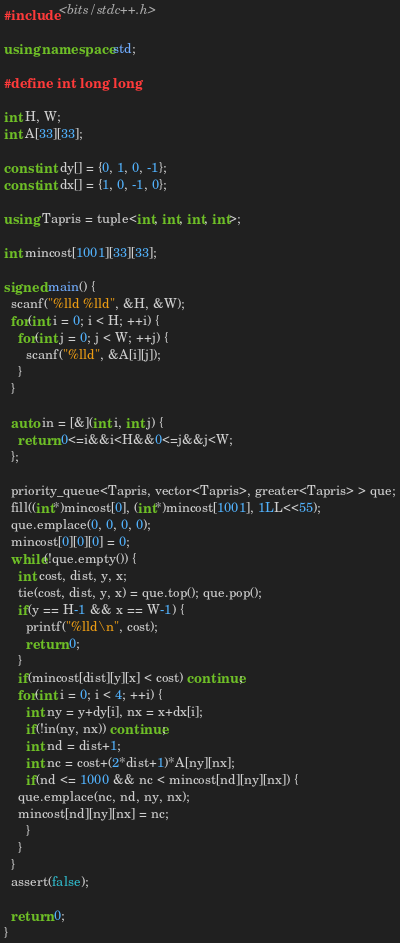Convert code to text. <code><loc_0><loc_0><loc_500><loc_500><_C++_>#include <bits/stdc++.h>

using namespace std;

#define int long long

int H, W;
int A[33][33];

const int dy[] = {0, 1, 0, -1};
const int dx[] = {1, 0, -1, 0};

using Tapris = tuple<int, int, int, int>;

int mincost[1001][33][33];

signed main() {
  scanf("%lld %lld", &H, &W);
  for(int i = 0; i < H; ++i) {
    for(int j = 0; j < W; ++j) {
      scanf("%lld", &A[i][j]);
    }
  }

  auto in = [&](int i, int j) {
    return 0<=i&&i<H&&0<=j&&j<W;
  };

  priority_queue<Tapris, vector<Tapris>, greater<Tapris> > que;
  fill((int*)mincost[0], (int*)mincost[1001], 1LL<<55);
  que.emplace(0, 0, 0, 0);
  mincost[0][0][0] = 0;
  while(!que.empty()) {
    int cost, dist, y, x;
    tie(cost, dist, y, x) = que.top(); que.pop();
    if(y == H-1 && x == W-1) {
      printf("%lld\n", cost);
      return 0;
    }
    if(mincost[dist][y][x] < cost) continue;
    for(int i = 0; i < 4; ++i) {
      int ny = y+dy[i], nx = x+dx[i];
      if(!in(ny, nx)) continue;
      int nd = dist+1;
      int nc = cost+(2*dist+1)*A[ny][nx];
      if(nd <= 1000 && nc < mincost[nd][ny][nx]) {
	que.emplace(nc, nd, ny, nx);
	mincost[nd][ny][nx] = nc;
      }
    }
  }
  assert(false);

  return 0;
}

</code> 